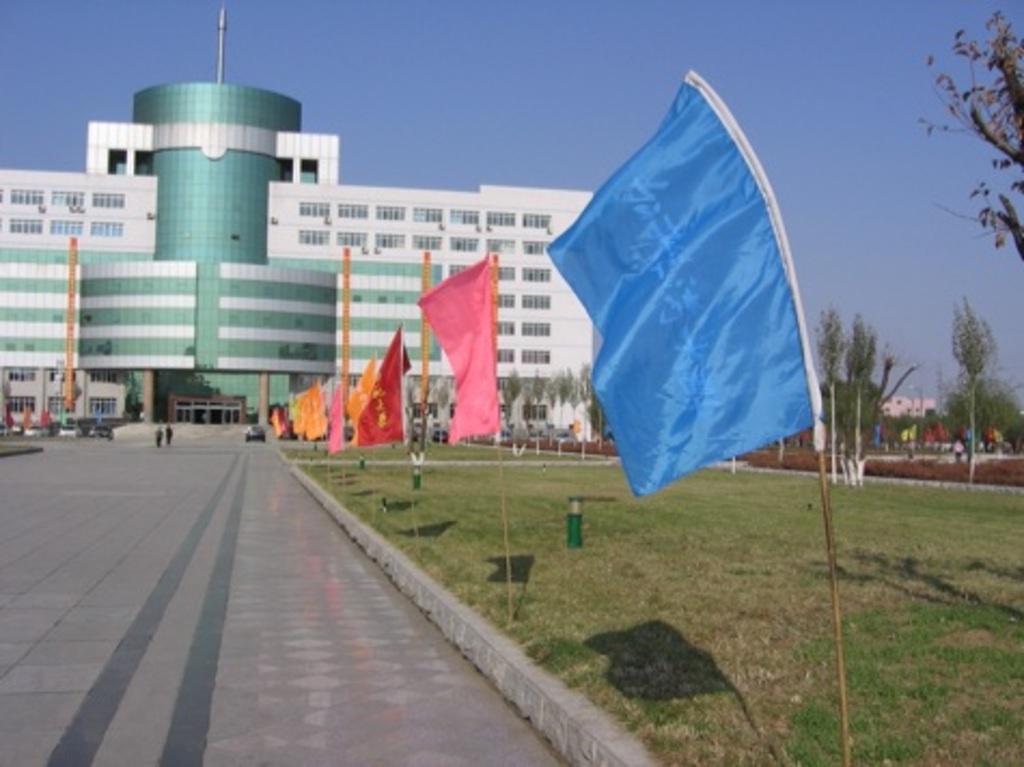Could you give a brief overview of what you see in this image? In this image I can see multi colored flags. I can also see two persons walking, background the building is in white and green color, sky in blue color. I can also see few trees in green color. 